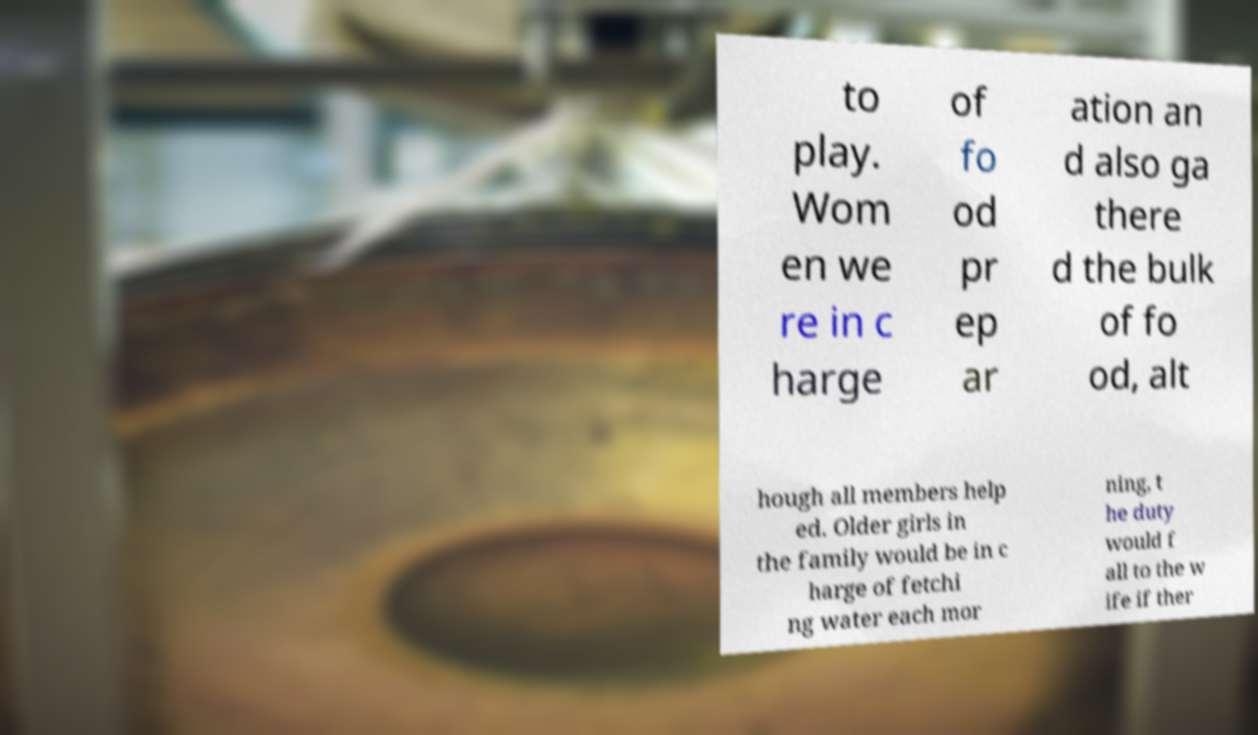What messages or text are displayed in this image? I need them in a readable, typed format. to play. Wom en we re in c harge of fo od pr ep ar ation an d also ga there d the bulk of fo od, alt hough all members help ed. Older girls in the family would be in c harge of fetchi ng water each mor ning, t he duty would f all to the w ife if ther 